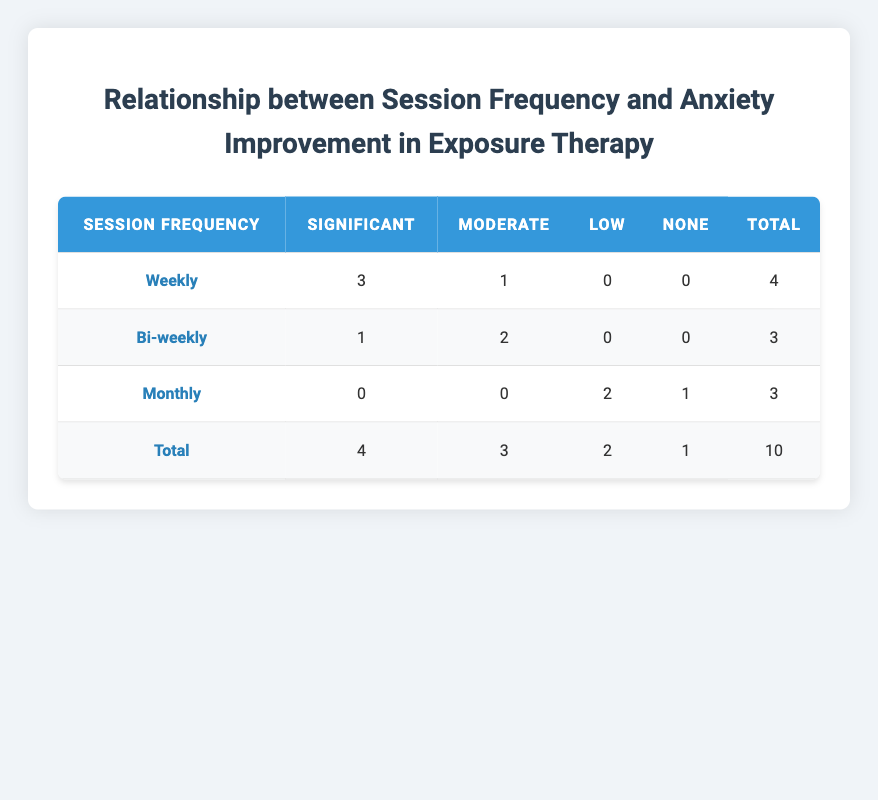What is the total number of participants receiving weekly sessions? In the 'Weekly' row of the table, there are 4 participants indicated by the 'Total' column entry for the 'Weekly' row.
Answer: 4 How many participants showed significant anxiety improvement during monthly sessions? In the 'Monthly' row, the entry under 'Significant' indicates 0 participants, meaning no one showed significant improvement during monthly sessions.
Answer: 0 Which session frequency had the highest number of participants showing moderate improvement? The 'Bi-weekly' row shows 2 participants with moderate improvement, which is higher than the 1 in the 'Weekly' row and 0 in the 'Monthly' row.
Answer: Bi-weekly What is the total number of participants who experienced low anxiety improvement? By looking at the entries for 'Low' in each session frequency, there are 2 participants in the 'Monthly' row and 0 in the others. So, total low improvement is 0 + 0 + 2 = 2.
Answer: 2 Is it true that all participants in monthly sessions showed some level of anxiety improvement? Looking at the 'Monthly' row, we see 2 participants had low improvement and 1 had none, meaning not all participants improved. Thus, the statement is false.
Answer: No How many more participants showed significant improvement with weekly sessions compared to bi-weekly sessions? Weekly sessions had 3 participants showing significant improvement while bi-weekly had 1. So, calculating the difference: 3 - 1 = 2 participants showed more improvement with weekly sessions.
Answer: 2 What is the average number of participants who showed significant improvement across all session frequencies? The total number of participants showing significant improvement is 4 (3 from weekly and 1 from bi-weekly). The total number of session entries is 10, hence the average is 4 / 10 = 0.4.
Answer: 0.4 Which session frequency has a total of 3 participants, and how many showed no improvement? The 'Monthly' session frequency has a total of 3 participants, out of which 1 showed no improvement (as indicated in the 'None' column).
Answer: Monthly; 1 What percentage of participants who received weekly sessions showed moderate improvement? The 'Weekly' row shows 4 total participants, and 1 showed moderate improvement. The percentage calculation is (1/4)*100 = 25%.
Answer: 25% 